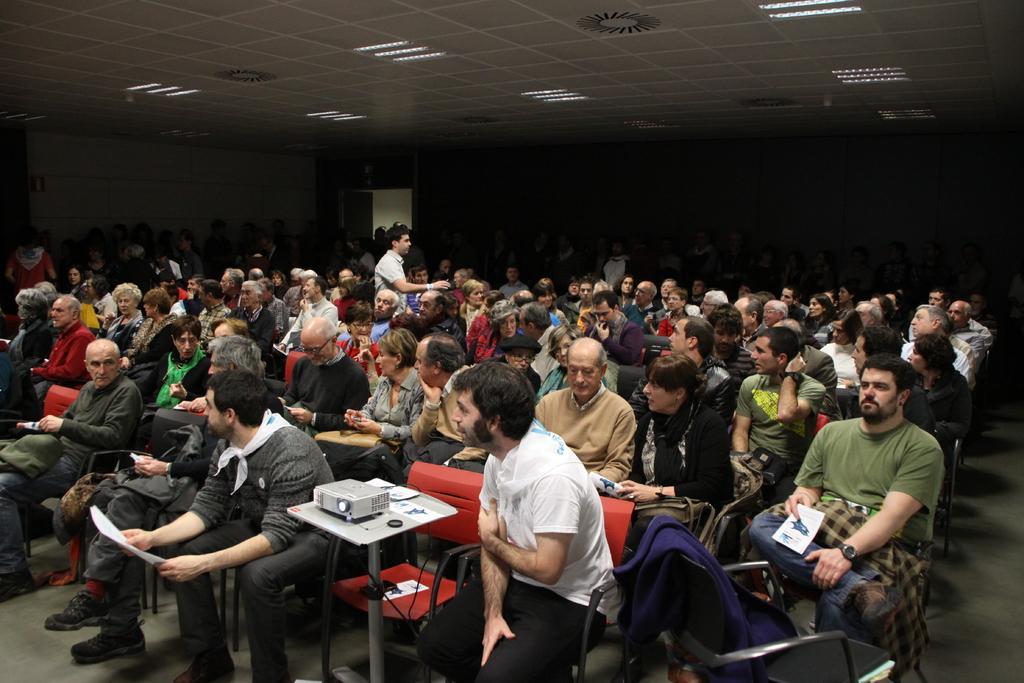Can you describe this image briefly? At the top we can see the ceiling and lights. In this picture we can see people sitting on the chairs and few people are standing. Few people are holding papers. On the right side of the picture we can see a jacket on a chair and the floor. 